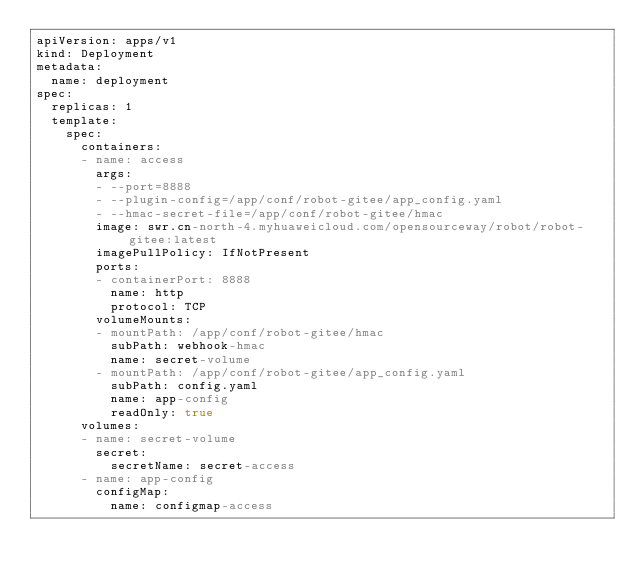<code> <loc_0><loc_0><loc_500><loc_500><_YAML_>apiVersion: apps/v1
kind: Deployment
metadata:
  name: deployment
spec:
  replicas: 1
  template:
    spec:
      containers:
      - name: access
        args:
        - --port=8888
        - --plugin-config=/app/conf/robot-gitee/app_config.yaml
        - --hmac-secret-file=/app/conf/robot-gitee/hmac
        image: swr.cn-north-4.myhuaweicloud.com/opensourceway/robot/robot-gitee:latest
        imagePullPolicy: IfNotPresent
        ports:
        - containerPort: 8888
          name: http
          protocol: TCP
        volumeMounts:
        - mountPath: /app/conf/robot-gitee/hmac
          subPath: webhook-hmac
          name: secret-volume
        - mountPath: /app/conf/robot-gitee/app_config.yaml
          subPath: config.yaml
          name: app-config
          readOnly: true
      volumes:
      - name: secret-volume
        secret:
          secretName: secret-access
      - name: app-config
        configMap:
          name: configmap-access
</code> 